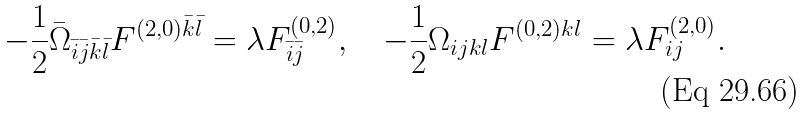<formula> <loc_0><loc_0><loc_500><loc_500>- \frac { 1 } { 2 } \bar { \Omega } _ { \bar { i } \bar { j } \bar { k } \bar { l } } F ^ { ( 2 , 0 ) \bar { k } \bar { l } } = \lambda F ^ { ( 0 , 2 ) } _ { \bar { i } \bar { j } } , \quad - \frac { 1 } { 2 } \Omega _ { i j k l } F ^ { ( 0 , 2 ) k l } = \lambda F ^ { ( 2 , 0 ) } _ { i j } .</formula> 